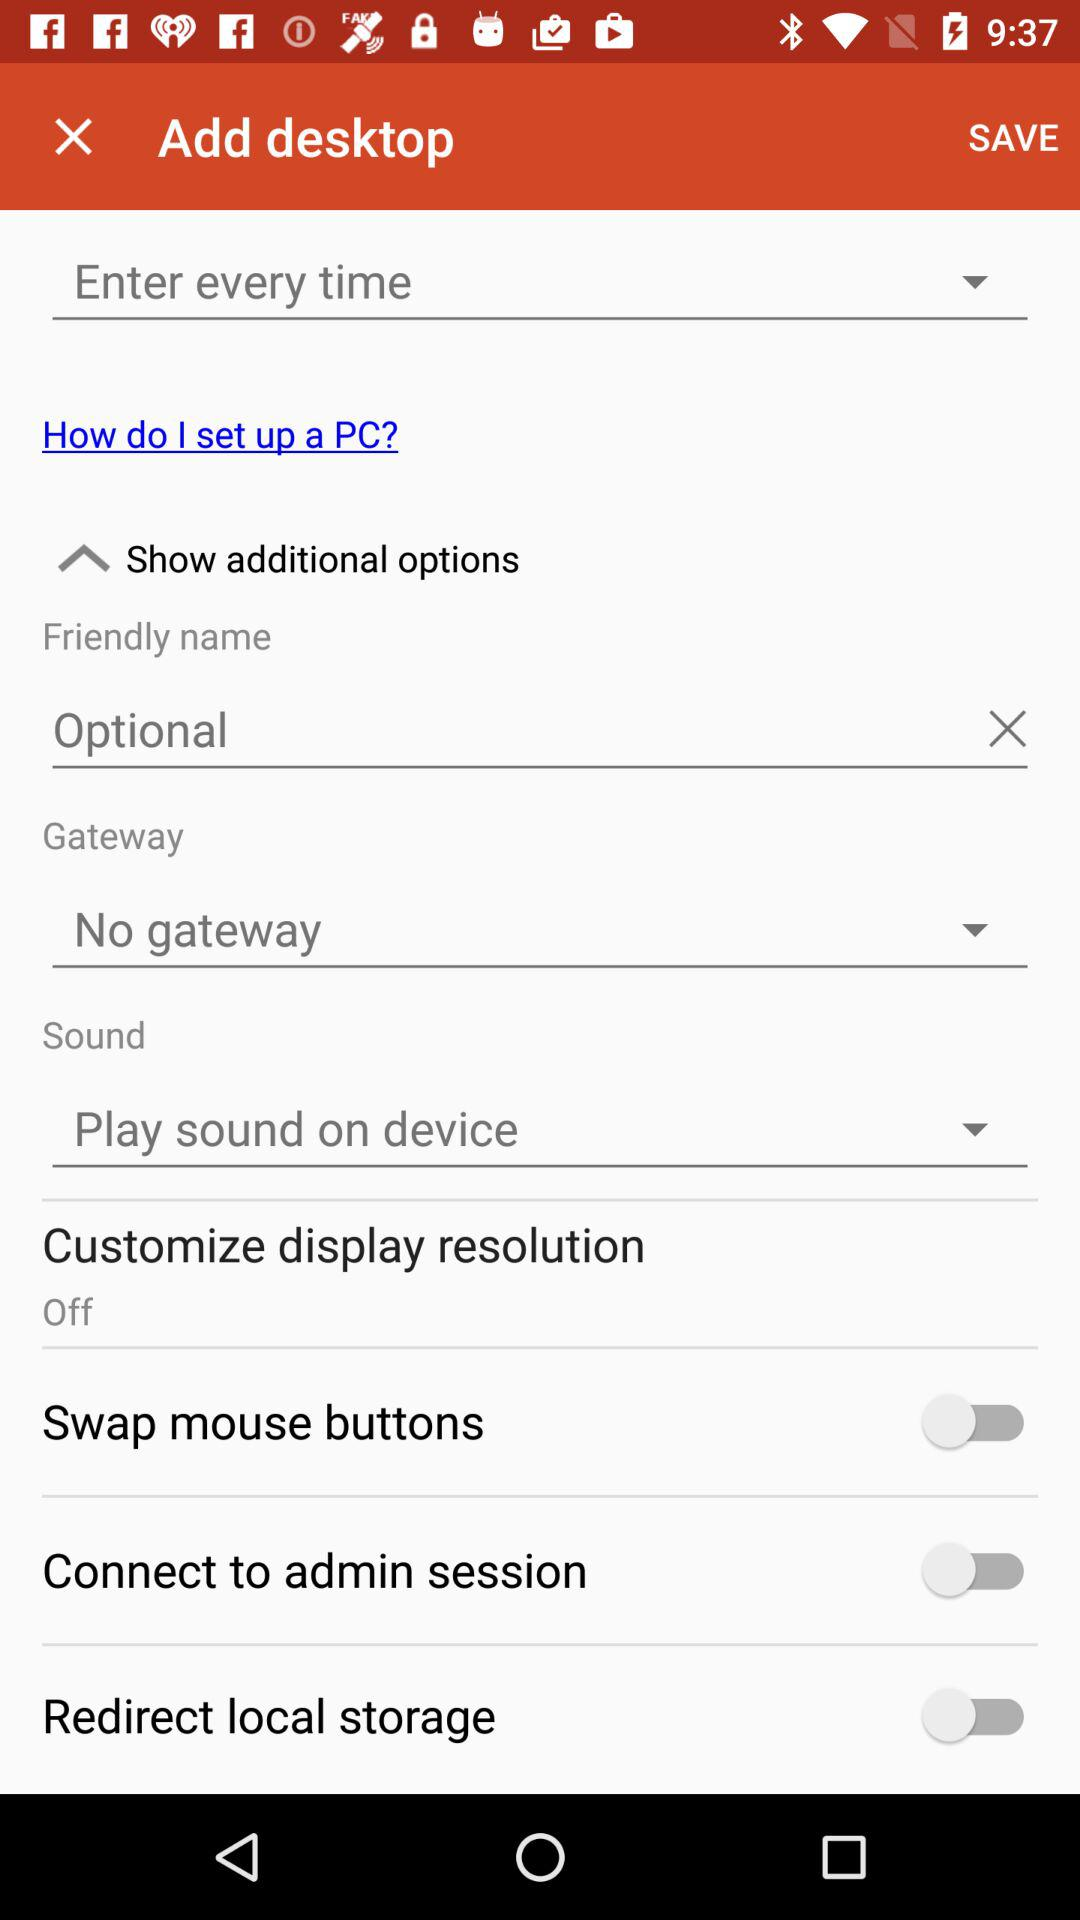What is the selected option in "Gateway"? The selected option is "No gateway". 